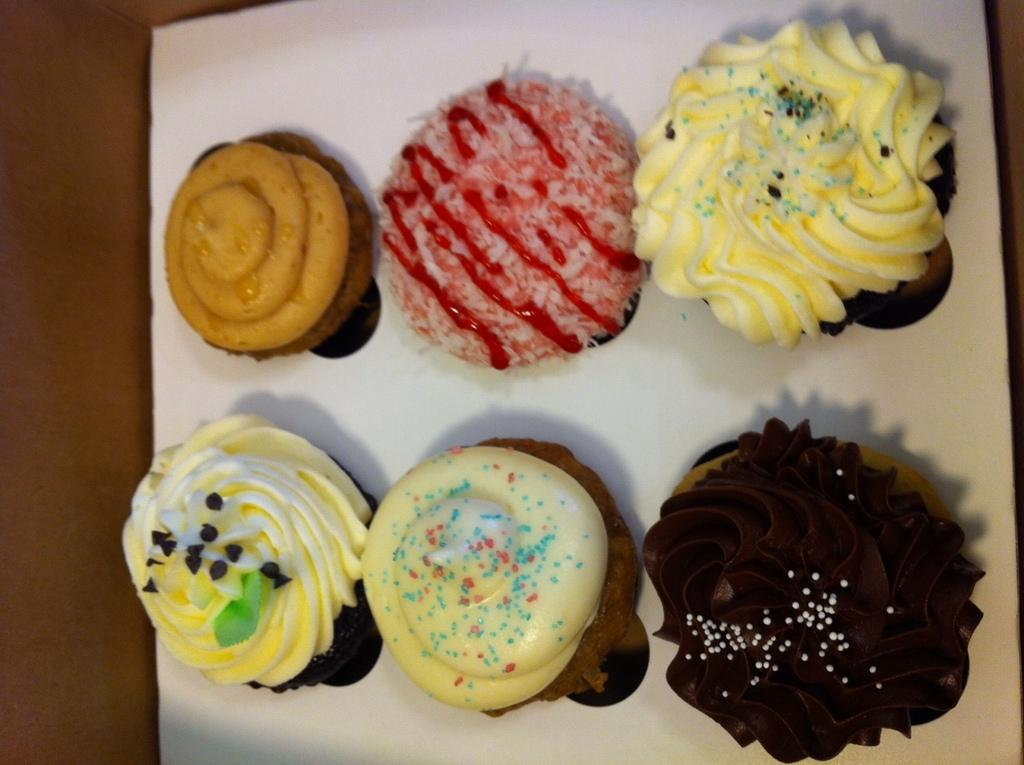What type of dessert can be seen in the image? The image contains cupcakes. How are the cupcakes arranged in the image? The cupcakes are placed on a white tray. Can you describe any other elements in the image? There is a blurred, brown area in the left corner of the image. Who is the creator of the cupcakes in the image? There is no information about the creator of the cupcakes in the image. 